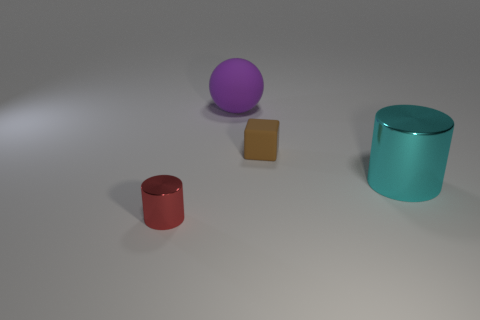How do the sizes of the objects in the image compare to each other? The cylinder is the largest object, followed by the purple ball which is slightly smaller. The red object, resembling a cylinder with a cut top, is smaller than the ball, and the tiny block is the smallest of all the objects presented. 